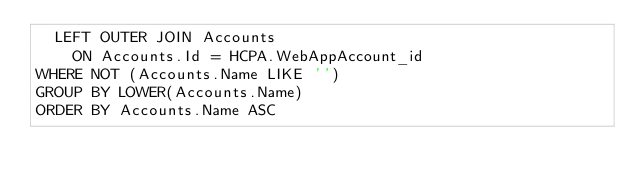Convert code to text. <code><loc_0><loc_0><loc_500><loc_500><_SQL_>	LEFT OUTER JOIN Accounts
		ON Accounts.Id = HCPA.WebAppAccount_id
WHERE NOT (Accounts.Name LIKE '')
GROUP BY LOWER(Accounts.Name)
ORDER BY Accounts.Name ASC</code> 